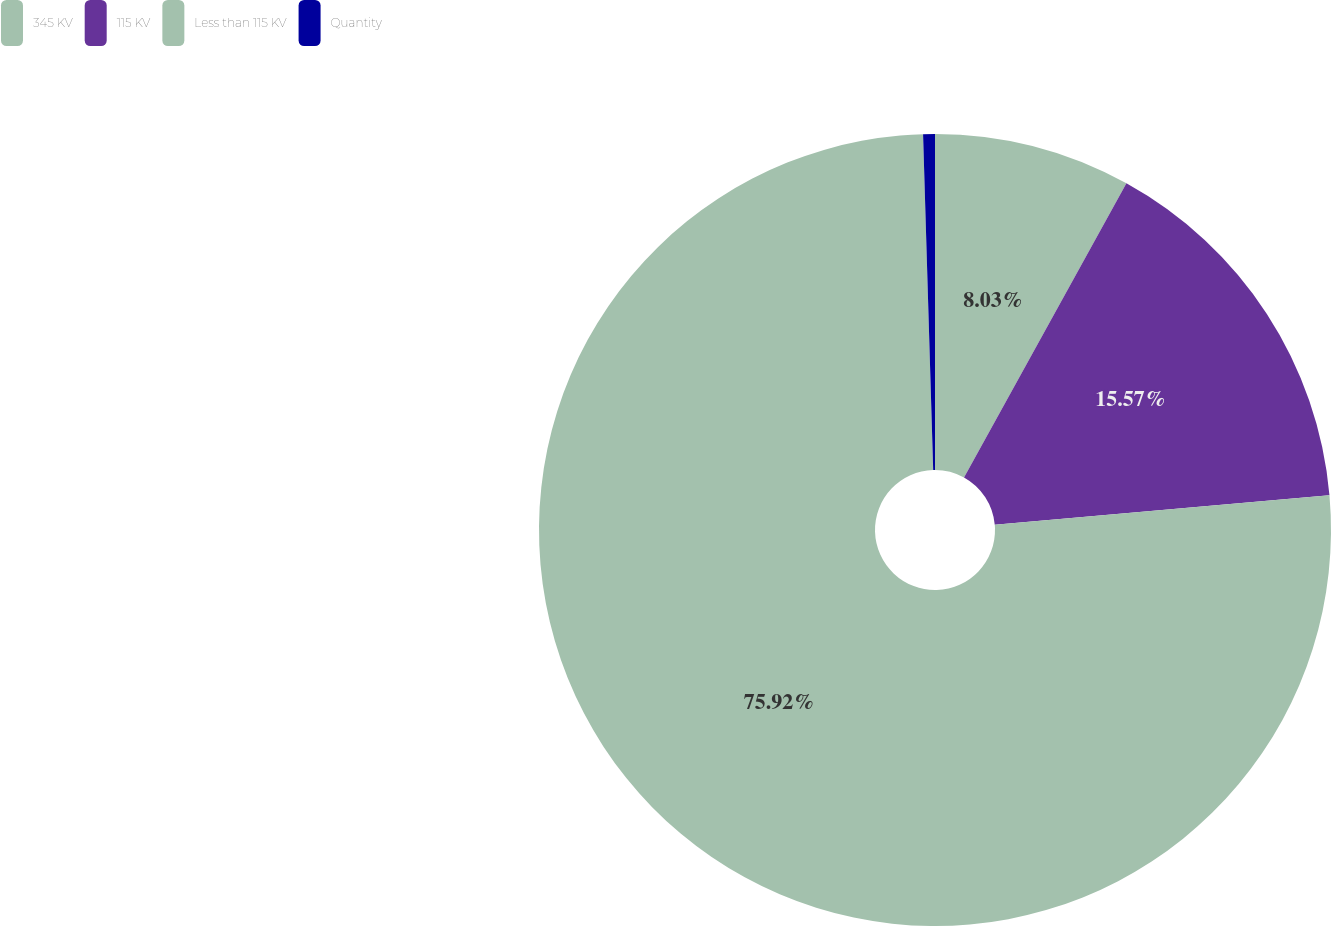Convert chart. <chart><loc_0><loc_0><loc_500><loc_500><pie_chart><fcel>345 KV<fcel>115 KV<fcel>Less than 115 KV<fcel>Quantity<nl><fcel>8.03%<fcel>15.57%<fcel>75.92%<fcel>0.48%<nl></chart> 